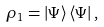<formula> <loc_0><loc_0><loc_500><loc_500>\rho _ { 1 } = \left | \Psi \right \rangle \left \langle \Psi \right | ,</formula> 